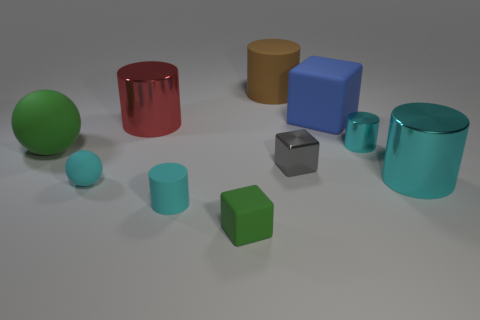Subtract all blue spheres. How many cyan cylinders are left? 3 Subtract all large cyan cylinders. How many cylinders are left? 4 Subtract all brown cylinders. How many cylinders are left? 4 Subtract all purple cylinders. Subtract all cyan spheres. How many cylinders are left? 5 Add 3 big rubber spheres. How many big rubber spheres exist? 4 Subtract 0 red blocks. How many objects are left? 10 Subtract all blocks. How many objects are left? 7 Subtract all tiny purple cubes. Subtract all small cyan rubber balls. How many objects are left? 9 Add 2 metallic things. How many metallic things are left? 6 